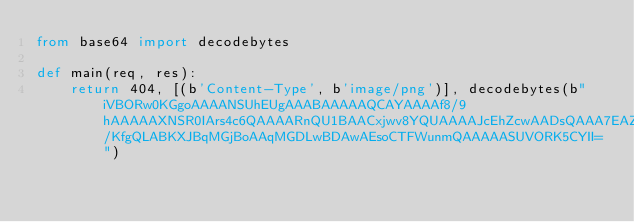Convert code to text. <code><loc_0><loc_0><loc_500><loc_500><_Python_>from base64 import decodebytes

def main(req, res):
    return 404, [(b'Content-Type', b'image/png')], decodebytes(b"iVBORw0KGgoAAAANSUhEUgAAABAAAAAQCAYAAAAf8/9hAAAAAXNSR0IArs4c6QAAAARnQU1BAACxjwv8YQUAAAAJcEhZcwAADsQAAA7EAZUrDhsAAAAhSURBVDhPY3wro/KfgQLABKXJBqMGjBoAAqMGDLwBDAwAEsoCTFWunmQAAAAASUVORK5CYII=")
</code> 